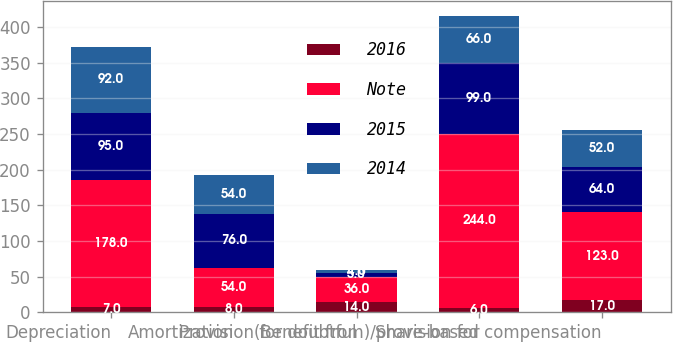Convert chart. <chart><loc_0><loc_0><loc_500><loc_500><stacked_bar_chart><ecel><fcel>Depreciation<fcel>Amortization<fcel>Provision for doubtful<fcel>(Benefit from)/provision for<fcel>Share-based compensation<nl><fcel>2016<fcel>7<fcel>8<fcel>14<fcel>6<fcel>17<nl><fcel>Note<fcel>178<fcel>54<fcel>36<fcel>244<fcel>123<nl><fcel>2015<fcel>95<fcel>76<fcel>5<fcel>99<fcel>64<nl><fcel>2014<fcel>92<fcel>54<fcel>4<fcel>66<fcel>52<nl></chart> 